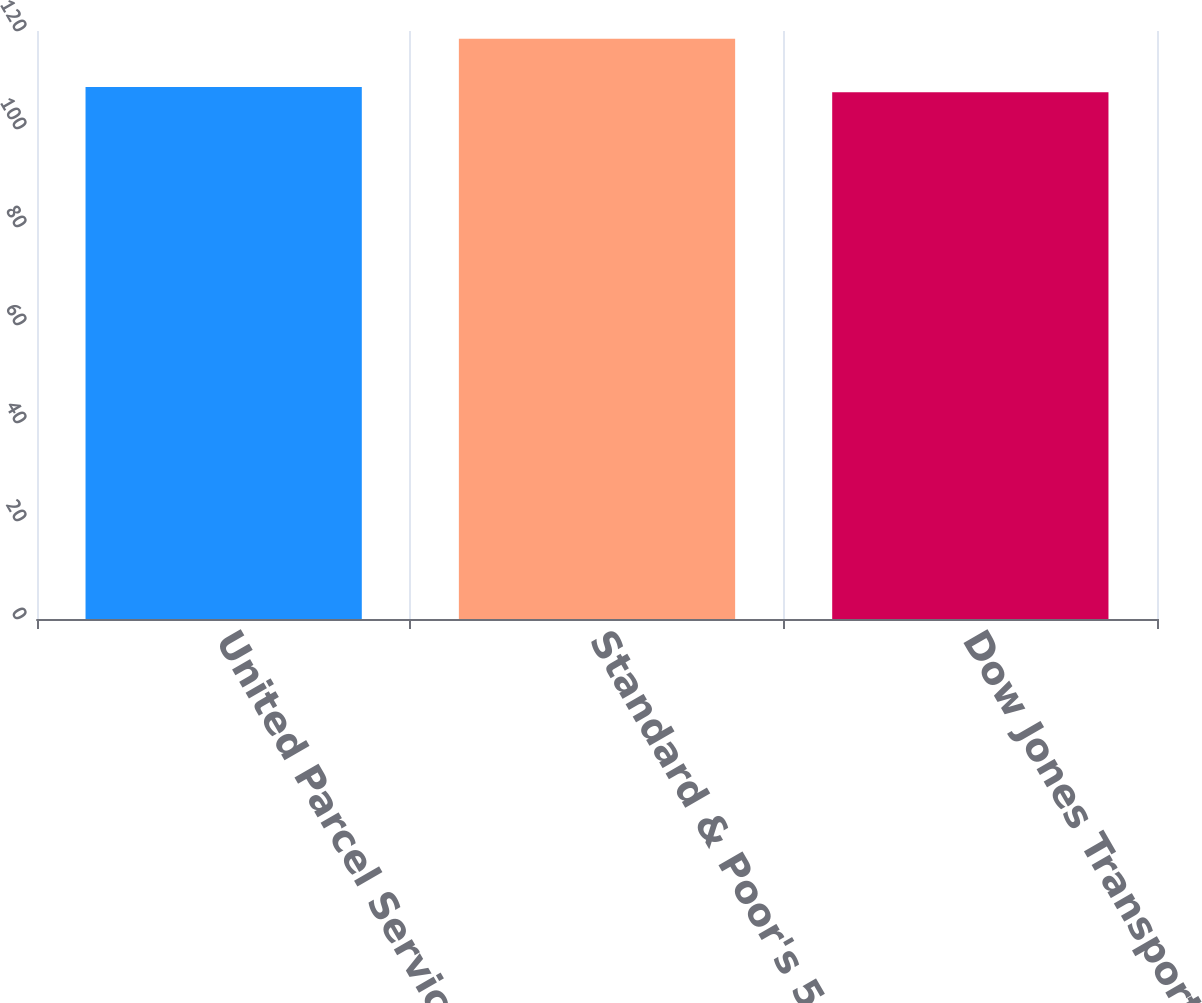Convert chart. <chart><loc_0><loc_0><loc_500><loc_500><bar_chart><fcel>United Parcel Service Inc<fcel>Standard & Poor's 500 Index<fcel>Dow Jones Transportation<nl><fcel>108.58<fcel>118.43<fcel>107.49<nl></chart> 